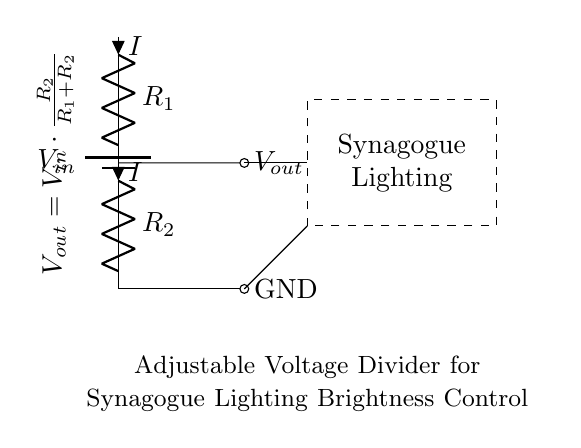What is the type of circuit used in the diagram? The diagram shows a voltage divider circuit, which divides input voltage into smaller output voltage based on the resistors used.
Answer: Voltage divider What is the notation for the input voltage? The input voltage is marked as V sub in, which denotes the voltage supplied to the circuit from the battery.
Answer: V in What is the purpose of the resistors R1 and R2 in this circuit? Resistors R1 and R2 are used to create a voltage divider, where the output voltage is based on the values of these resistors.
Answer: Adjust brightness What is the relationship between Vout and Vin in this circuit? The output voltage V out is calculated using the formula V out equals V in times the fraction of R2 over the sum of R1 and R2.
Answer: V out = V in * (R2 / (R1 + R2)) How does changing R2 affect the output voltage? Increasing the resistance of R2 increases the output voltage, while decreasing R2 will decrease the output voltage, according to the voltage divider formula.
Answer: Increases output What happens to the current in the circuit if R1 is doubled? Doubling R1 while keeping R2 constant will decrease the overall current flowing through the circuit, according to Ohm’s law and the voltage divider relationship.
Answer: Decreases current 